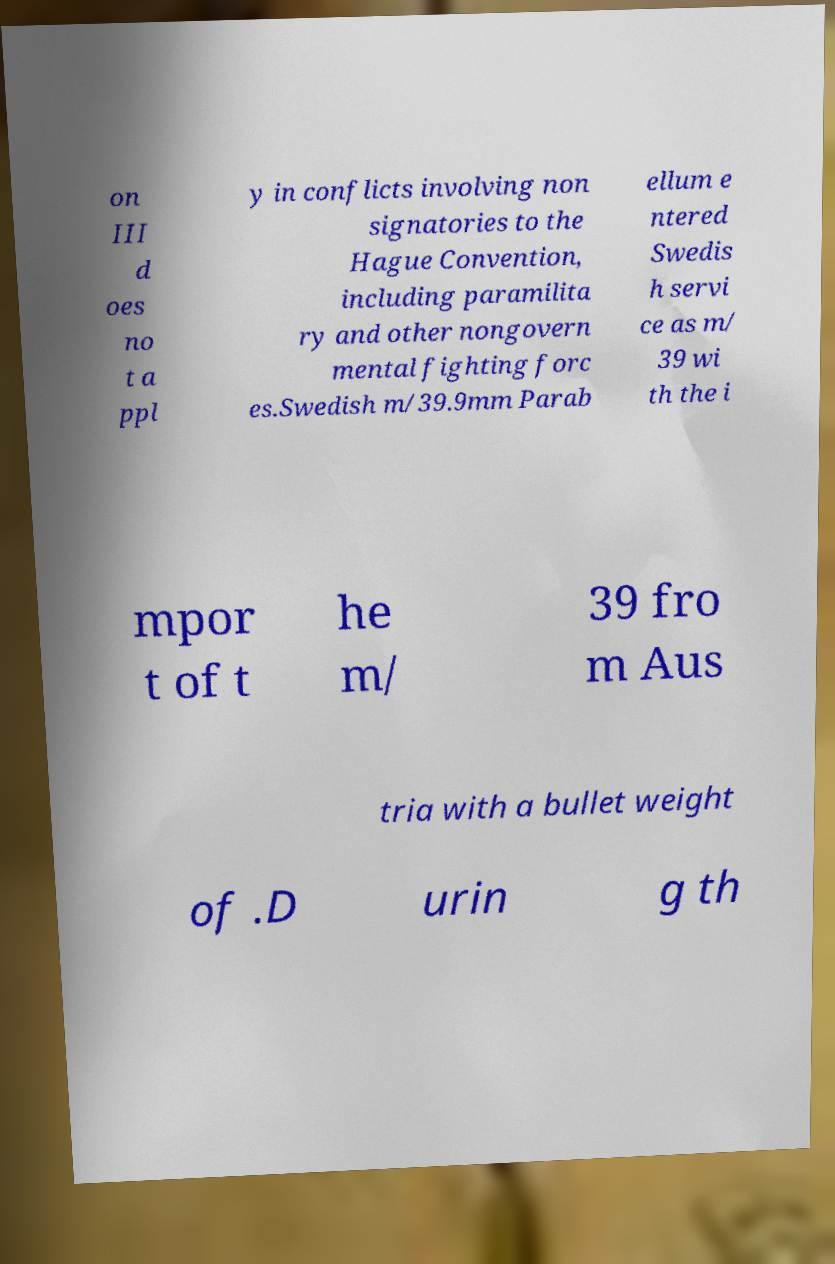I need the written content from this picture converted into text. Can you do that? on III d oes no t a ppl y in conflicts involving non signatories to the Hague Convention, including paramilita ry and other nongovern mental fighting forc es.Swedish m/39.9mm Parab ellum e ntered Swedis h servi ce as m/ 39 wi th the i mpor t of t he m/ 39 fro m Aus tria with a bullet weight of .D urin g th 